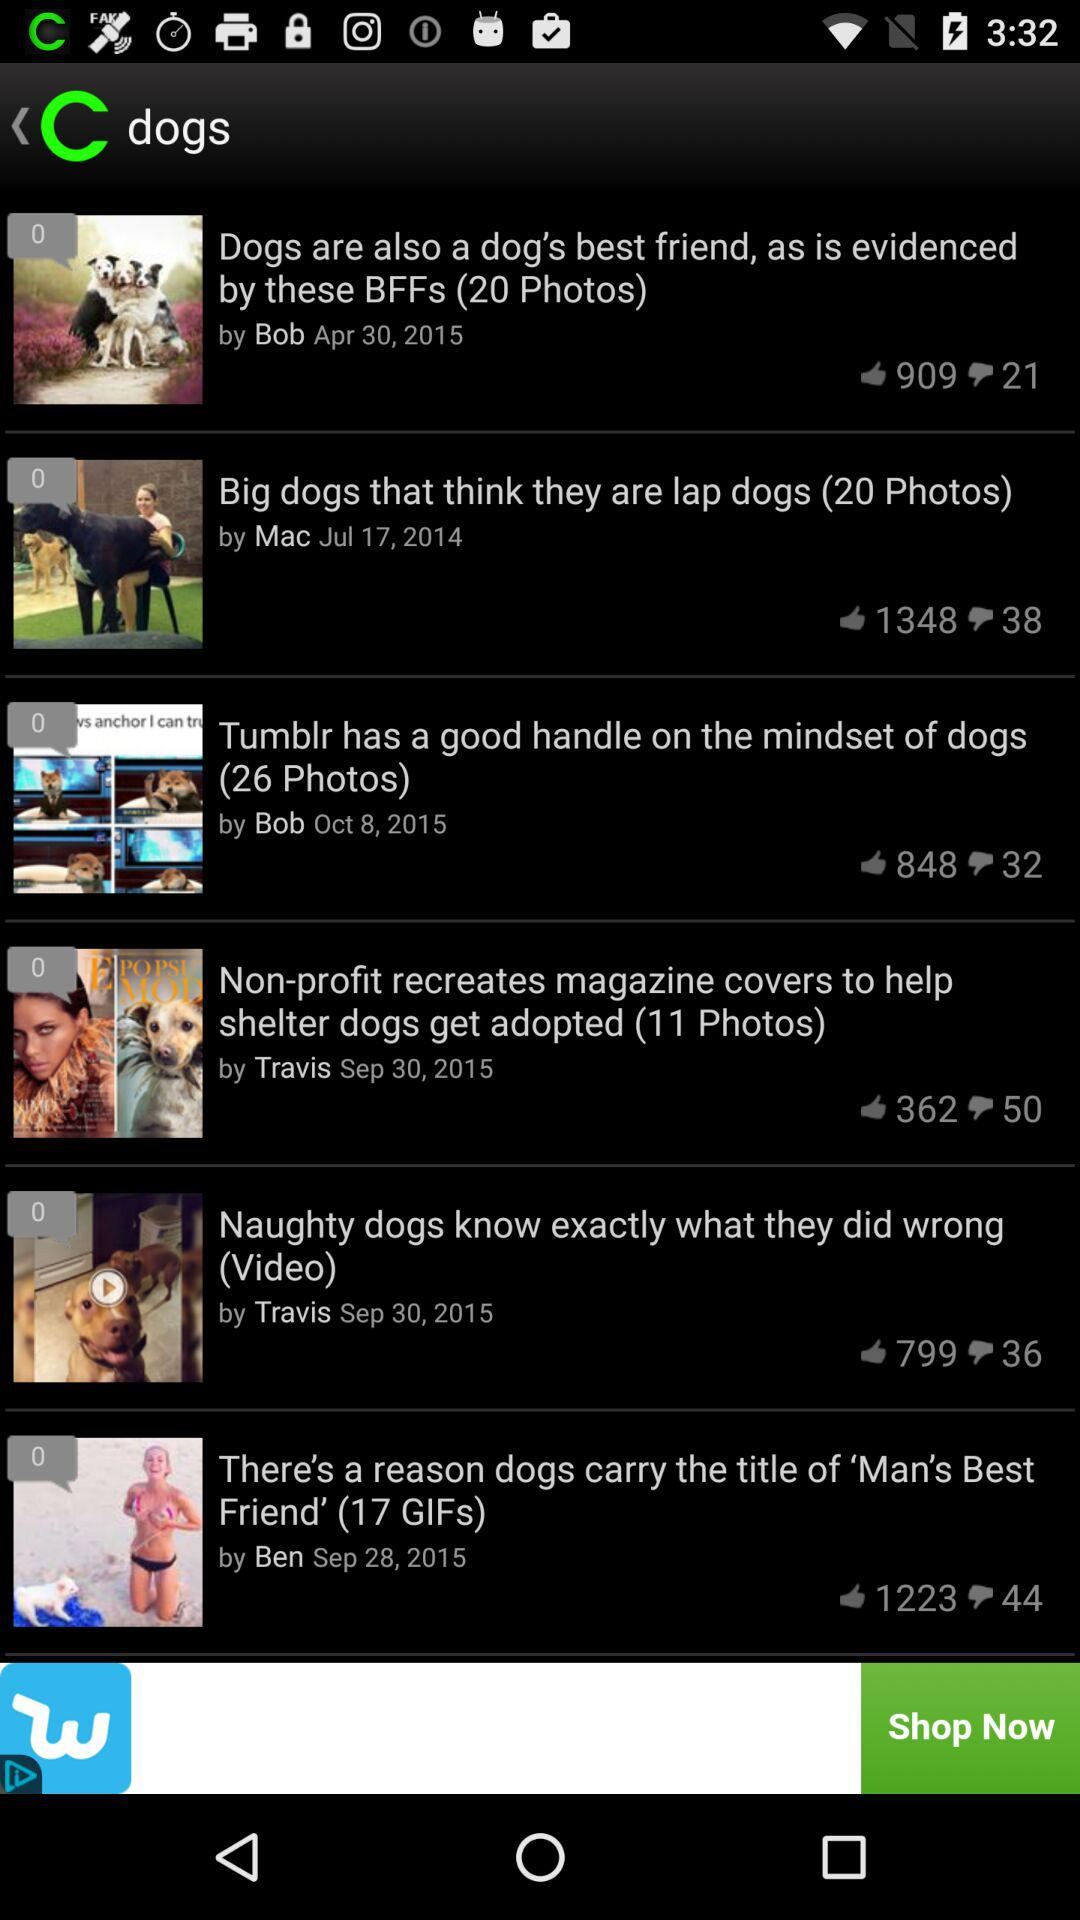What is the number of likes on the post "Big dogs"? The number of likes is 1348. 